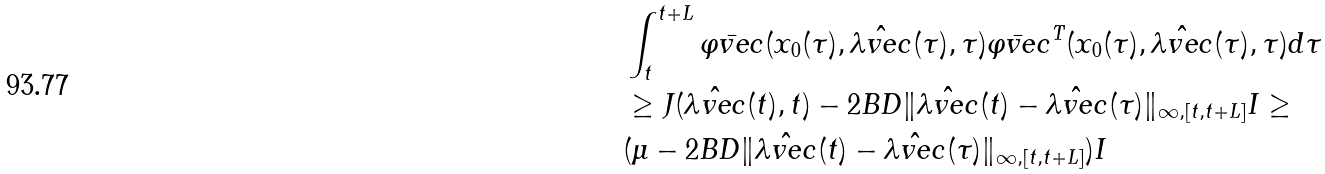<formula> <loc_0><loc_0><loc_500><loc_500>& \int _ { t } ^ { t + L } \bar { \varphi v e c } ( x _ { 0 } ( \tau ) , \hat { \lambda v e c } ( \tau ) , \tau ) \bar { \varphi v e c } ^ { T } ( x _ { 0 } ( \tau ) , \hat { \lambda v e c } ( \tau ) , \tau ) d \tau \\ & \geq J ( \hat { \lambda v e c } ( t ) , t ) - 2 B D \| \hat { \lambda v e c } ( t ) - \hat { \lambda v e c } ( \tau ) \| _ { \infty , [ t , t + L ] } I \geq \\ & ( \mu - 2 B D \| \hat { \lambda v e c } ( t ) - \hat { \lambda v e c } ( \tau ) \| _ { \infty , [ t , t + L ] } ) I</formula> 